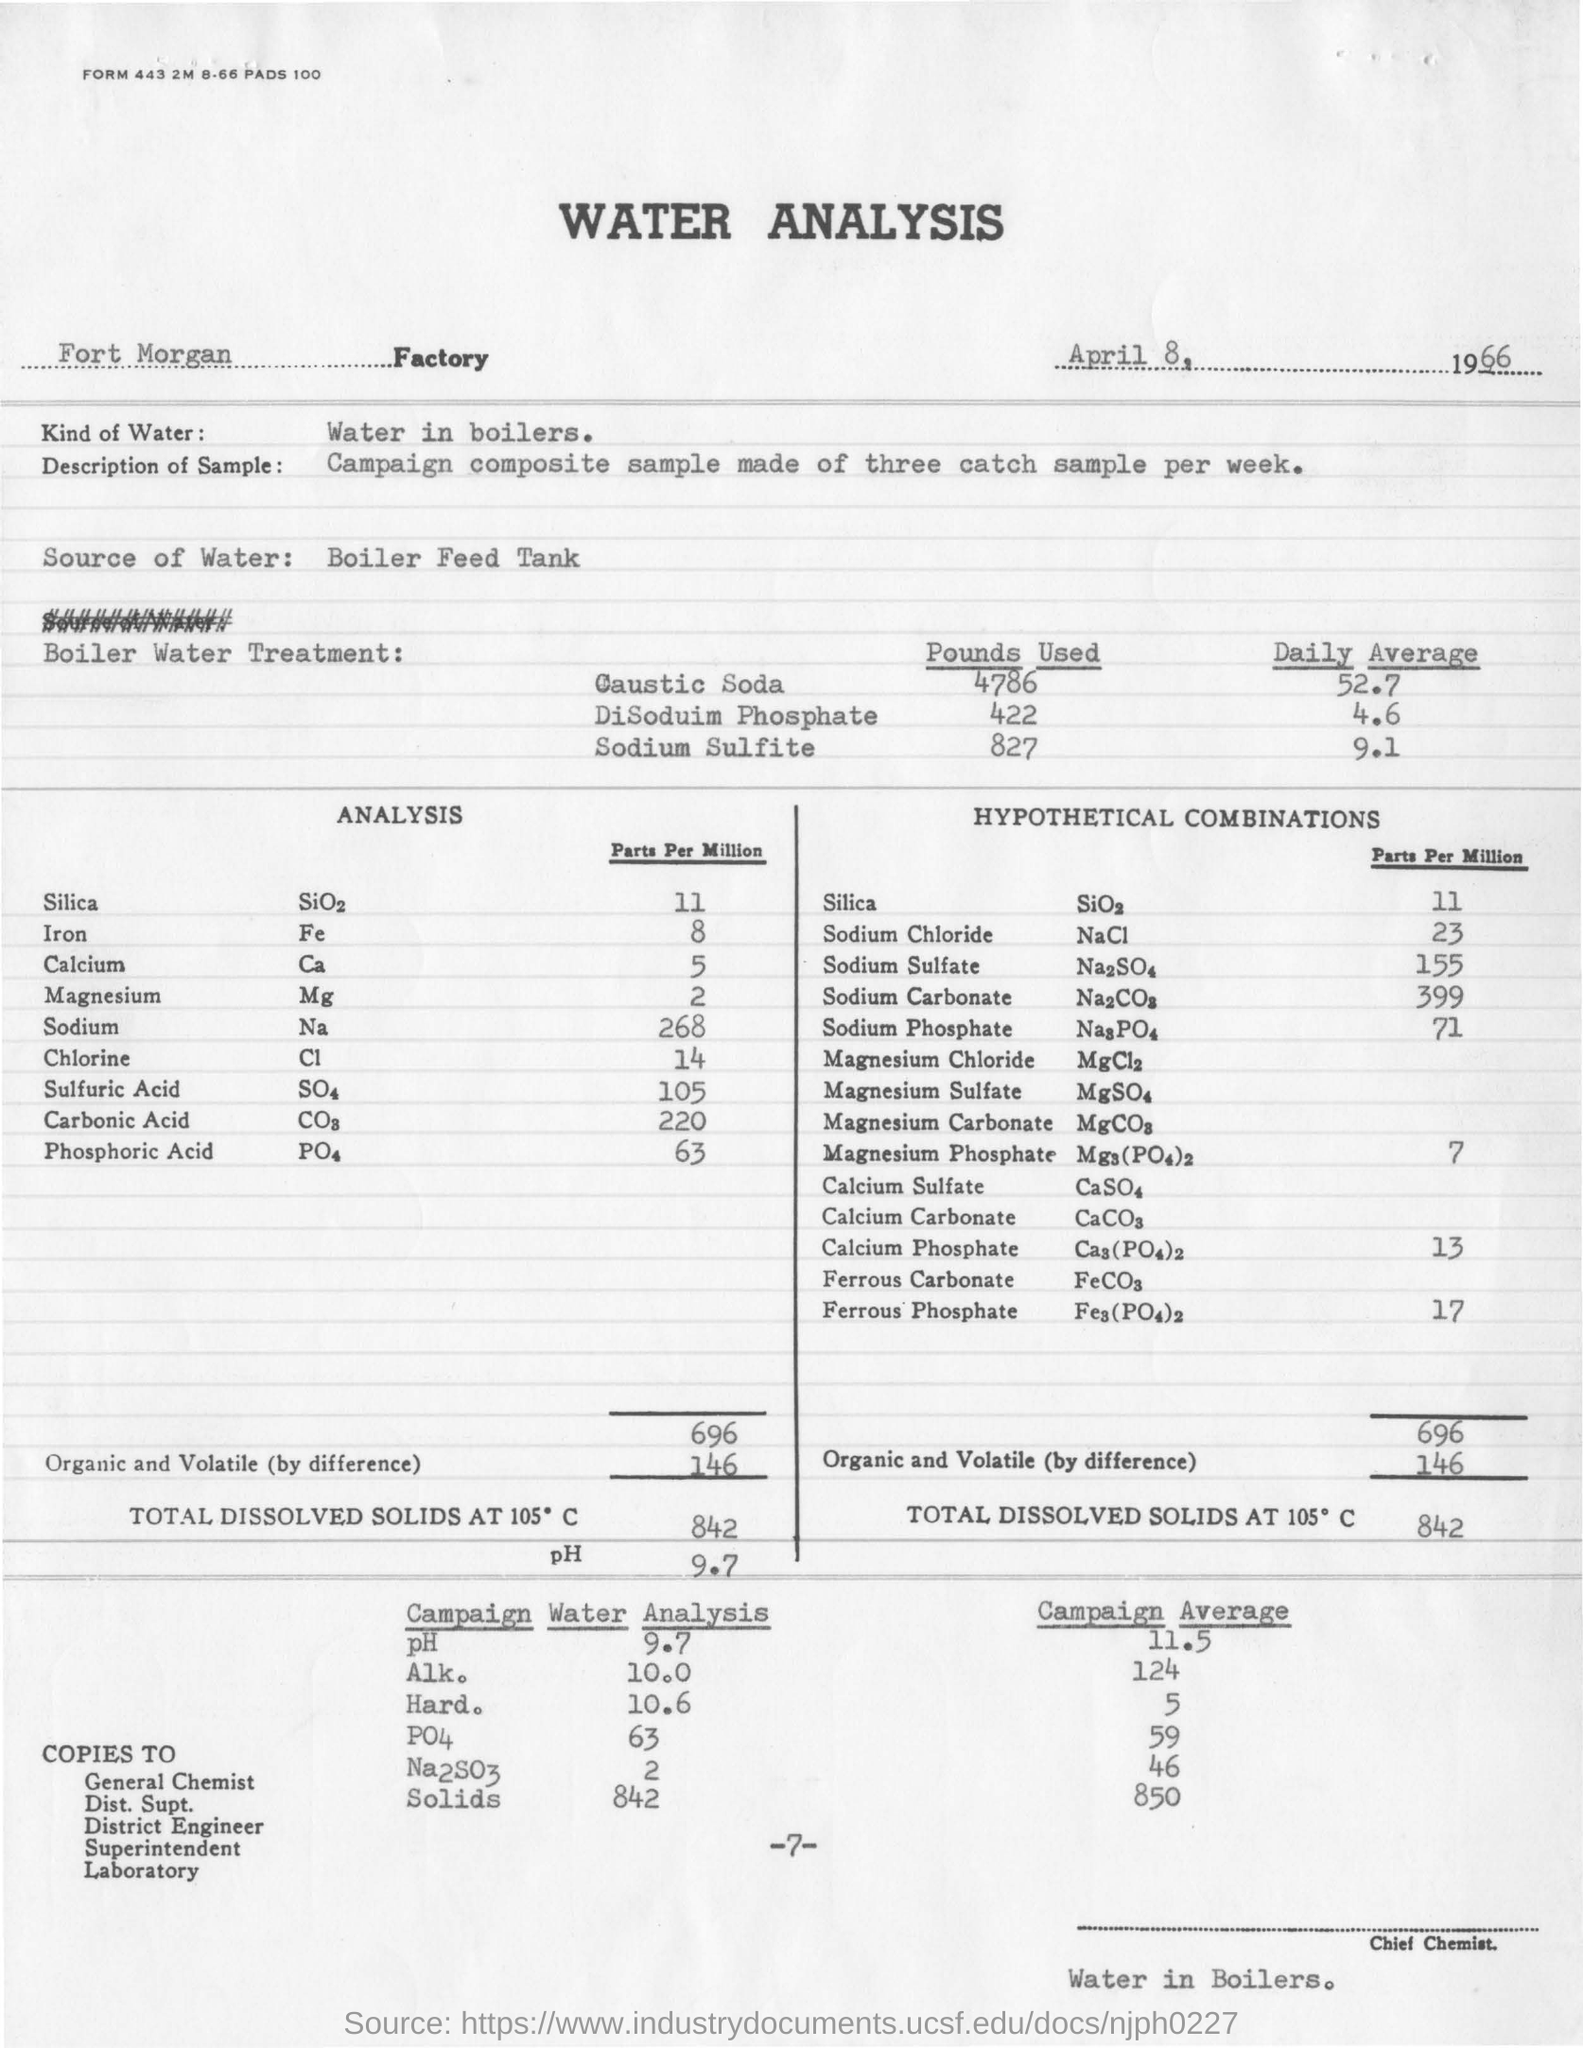What is the name of the factory ?
Provide a short and direct response. Fort morgan factory. What is the kind of water used in the analysis ?
Provide a short and direct response. Water in boilers. What is the parts per million value of sodium ?
Keep it short and to the point. 268. How many pounds of caustic soda are used in boiler water treatment ?
Provide a short and direct response. 4786. What is the campaign average value of solids ?
Keep it short and to the point. 850. What is the daily average value of sodium sulfite used in boiler water treatment ?
Keep it short and to the point. 9.1. What is the ph value obtained in the water analysis ?
Keep it short and to the point. 9.7. 